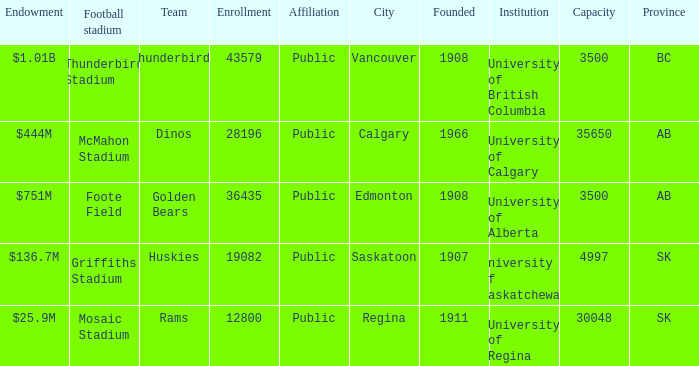What is the year founded for the team Dinos? 1966.0. 